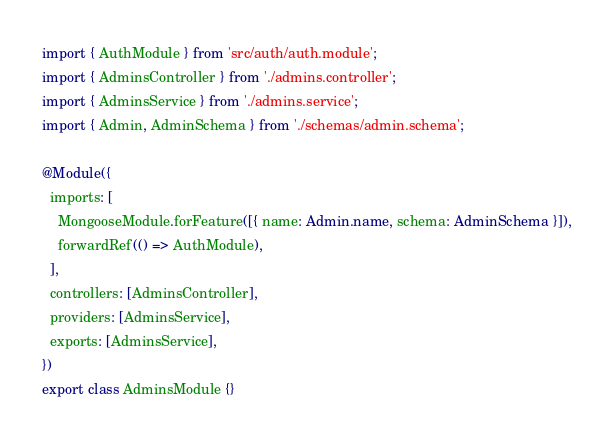<code> <loc_0><loc_0><loc_500><loc_500><_TypeScript_>import { AuthModule } from 'src/auth/auth.module';
import { AdminsController } from './admins.controller';
import { AdminsService } from './admins.service';
import { Admin, AdminSchema } from './schemas/admin.schema';

@Module({
  imports: [
    MongooseModule.forFeature([{ name: Admin.name, schema: AdminSchema }]),
    forwardRef(() => AuthModule),
  ],
  controllers: [AdminsController],
  providers: [AdminsService],
  exports: [AdminsService],
})
export class AdminsModule {}
</code> 